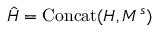<formula> <loc_0><loc_0><loc_500><loc_500>\hat { H } = C o n c a t ( H , M ^ { s } )</formula> 